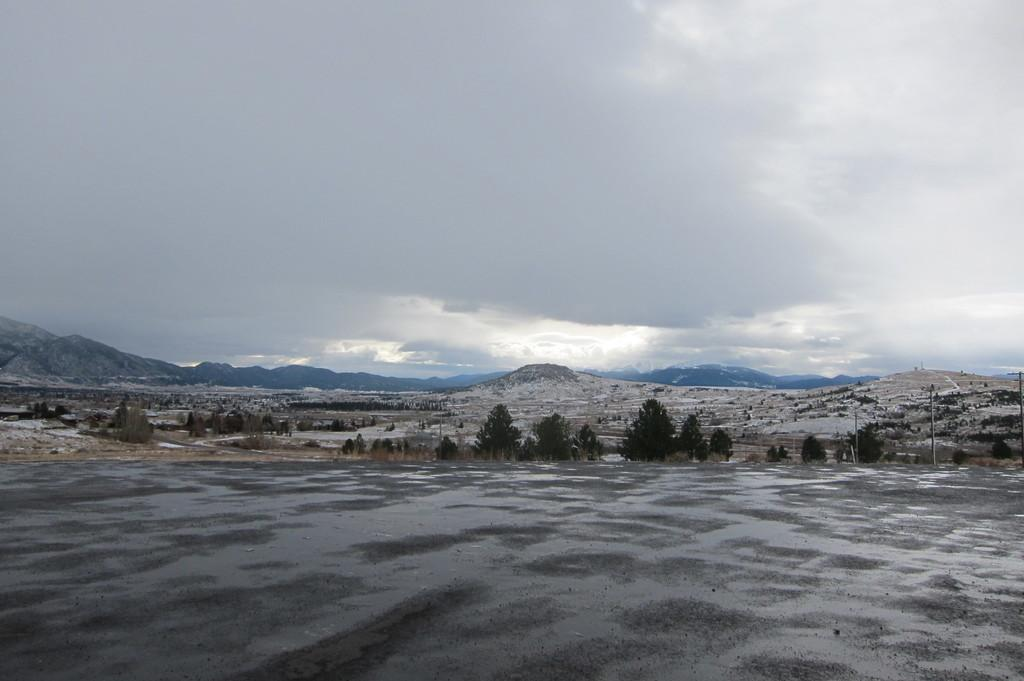What type of vegetation can be seen in the image? There are trees in the image. What structure is present in the image? There is a pole in the image. What type of landscape feature is visible in the image? There are hills in the image. What type of geographical feature can be seen in the background of the image? There are mountains in the background of the image. What is visible in the sky in the image? Clouds are visible in the sky. What type of scissors are being used to trim the trees in the image? There are no scissors present in the image, nor are any trees being trimmed. 